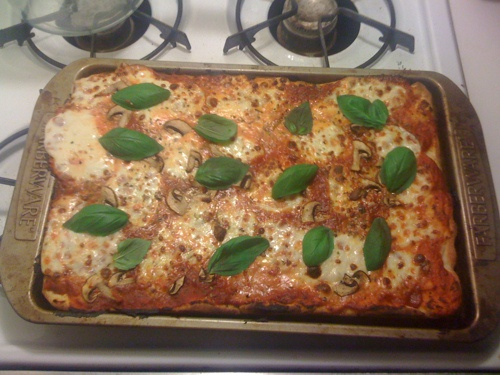Describe the objects in this image and their specific colors. I can see pizza in darkgray, brown, darkgreen, and tan tones and oven in darkgray, gray, lightgray, and black tones in this image. 